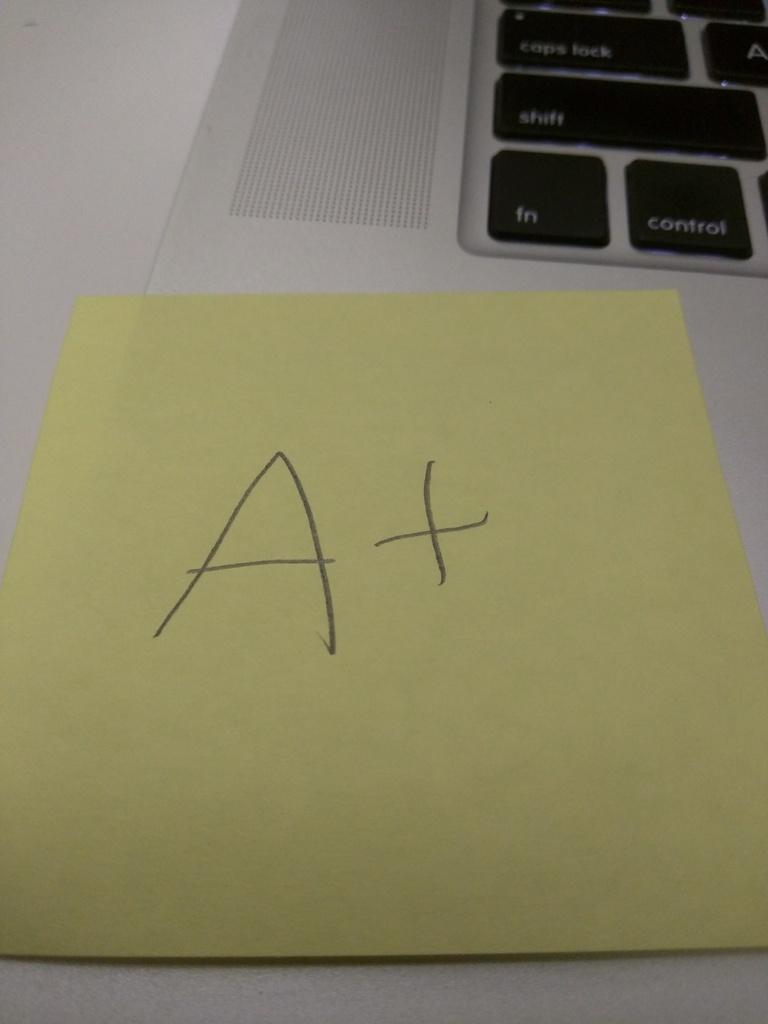What grade did this person receive?
Your answer should be very brief. A+. 